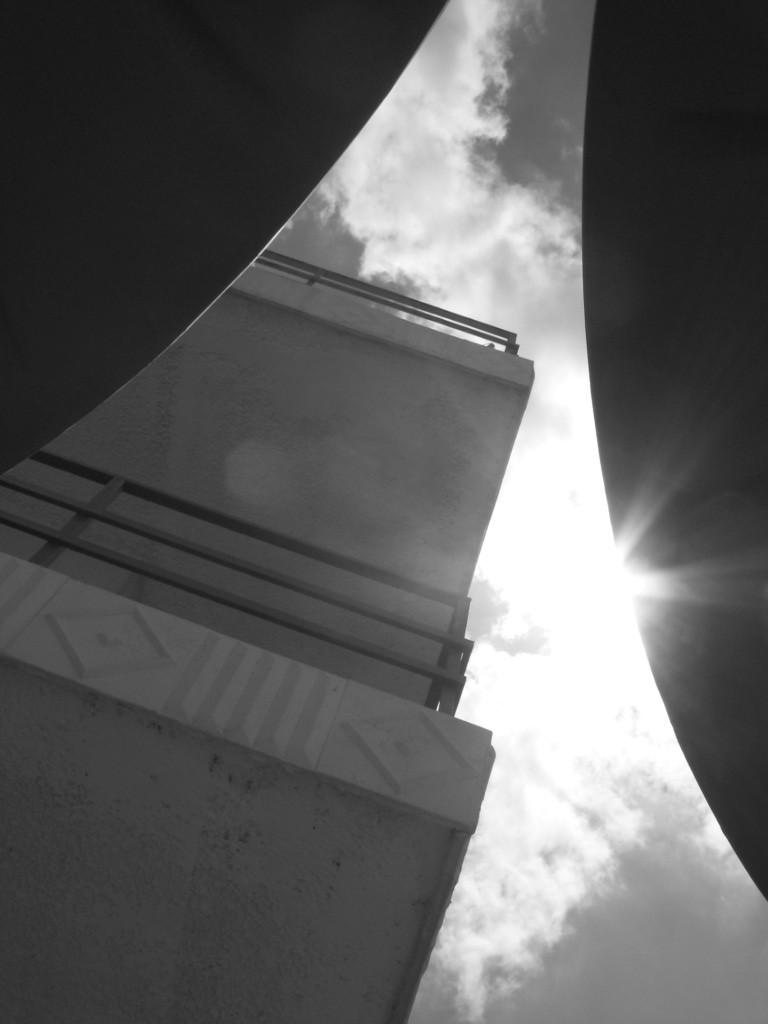What type of structure is present in the image? There is a building in the image. What can be seen above the building in the image? The sky is visible at the top of the image. Are there any architectural features present in the image? Yes, there is railing in the image. How many icicles are hanging from the wing of the expert in the image? There is no expert or wing present in the image, and therefore no icicles can be observed. 